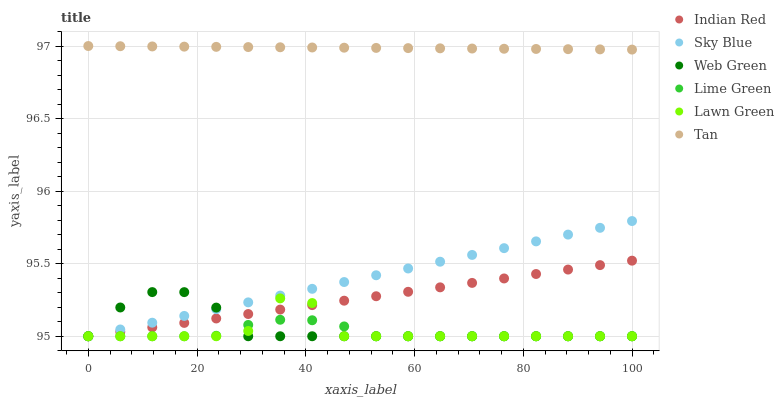Does Lime Green have the minimum area under the curve?
Answer yes or no. Yes. Does Tan have the maximum area under the curve?
Answer yes or no. Yes. Does Web Green have the minimum area under the curve?
Answer yes or no. No. Does Web Green have the maximum area under the curve?
Answer yes or no. No. Is Tan the smoothest?
Answer yes or no. Yes. Is Lawn Green the roughest?
Answer yes or no. Yes. Is Web Green the smoothest?
Answer yes or no. No. Is Web Green the roughest?
Answer yes or no. No. Does Lawn Green have the lowest value?
Answer yes or no. Yes. Does Tan have the lowest value?
Answer yes or no. No. Does Tan have the highest value?
Answer yes or no. Yes. Does Web Green have the highest value?
Answer yes or no. No. Is Sky Blue less than Tan?
Answer yes or no. Yes. Is Tan greater than Lime Green?
Answer yes or no. Yes. Does Lawn Green intersect Sky Blue?
Answer yes or no. Yes. Is Lawn Green less than Sky Blue?
Answer yes or no. No. Is Lawn Green greater than Sky Blue?
Answer yes or no. No. Does Sky Blue intersect Tan?
Answer yes or no. No. 